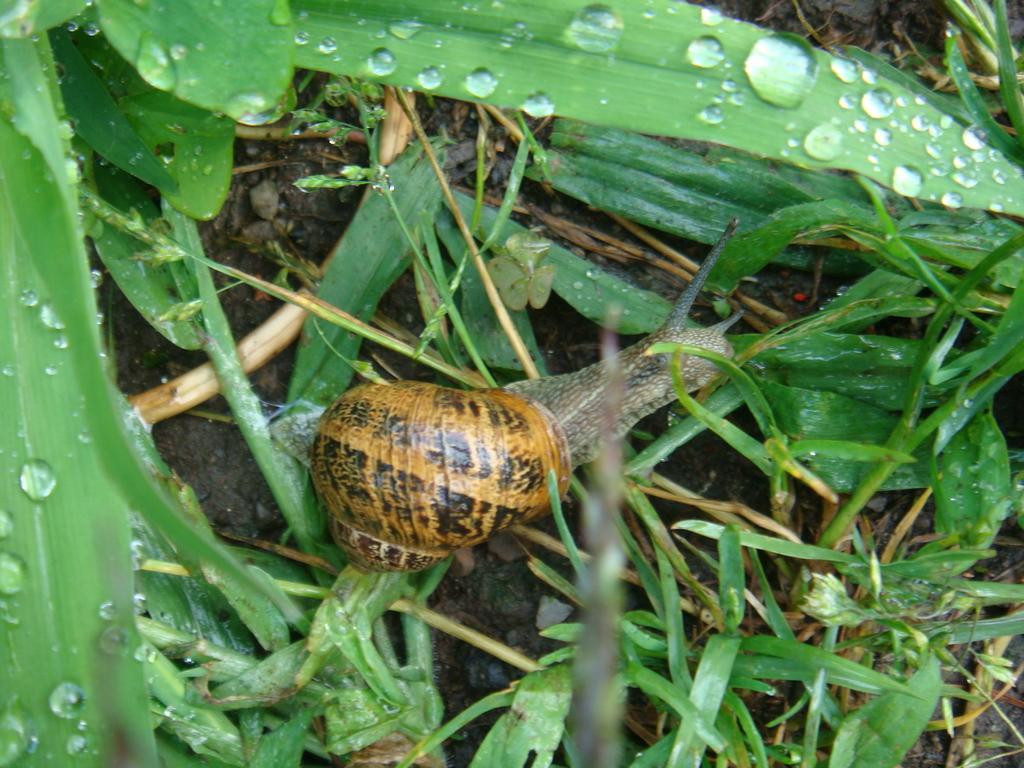Could you give a brief overview of what you see in this image? In the image there is a snail on the grass. 